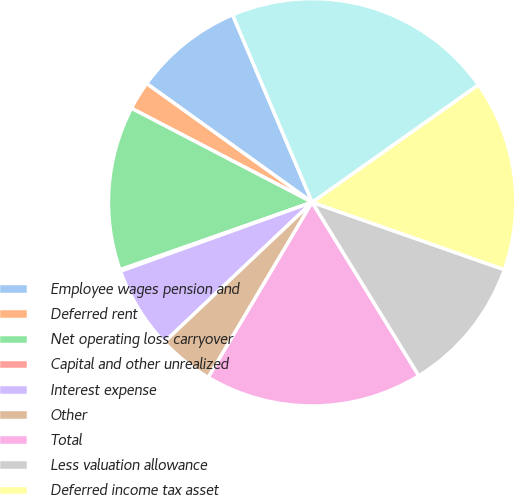Convert chart to OTSL. <chart><loc_0><loc_0><loc_500><loc_500><pie_chart><fcel>Employee wages pension and<fcel>Deferred rent<fcel>Net operating loss carryover<fcel>Capital and other unrealized<fcel>Interest expense<fcel>Other<fcel>Total<fcel>Less valuation allowance<fcel>Deferred income tax asset<fcel>Fixed assets and intangible<nl><fcel>8.71%<fcel>2.27%<fcel>13.01%<fcel>0.12%<fcel>6.56%<fcel>4.42%<fcel>17.3%<fcel>10.86%<fcel>15.16%<fcel>21.6%<nl></chart> 